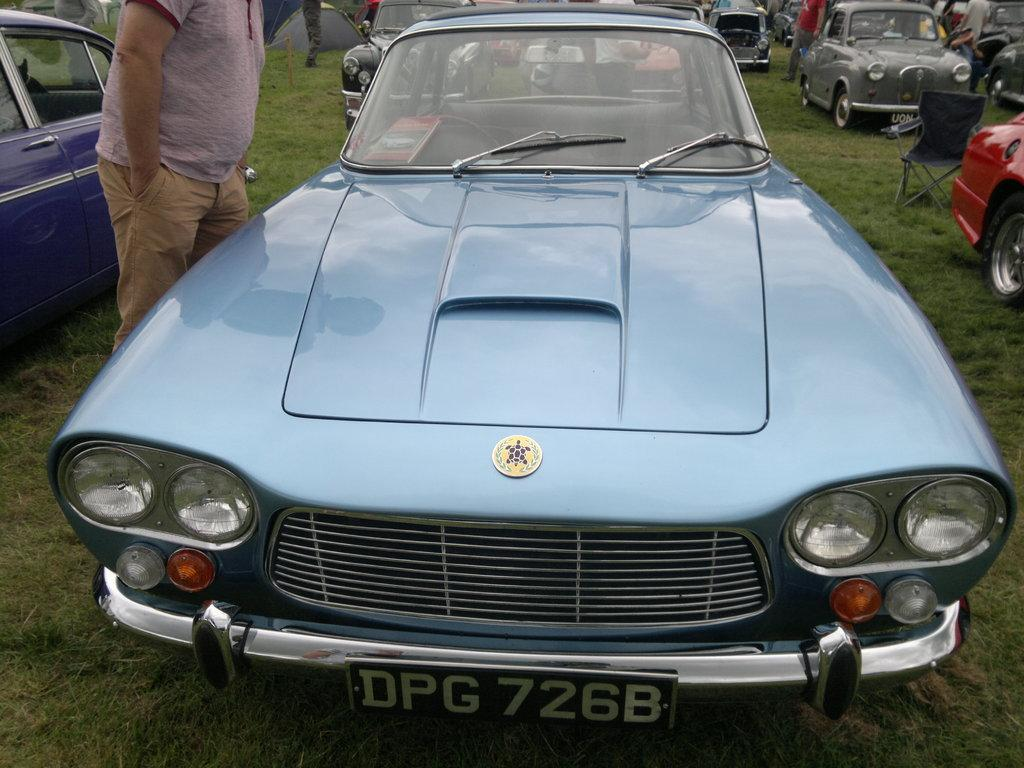What types of objects can be seen in the image? There are vehicles in the image. Are there any living beings present in the image? Yes, there are persons in the image. What can be seen beneath the vehicles and persons? The ground is visible in the image. What type of vegetation is present on the ground? There is grass on the ground in the image. What type of prose is being recited by the cork in the image? There is no cork or prose present in the image. Does the existence of the vehicles and persons in the image prove the existence of a higher power? The image does not provide any information about the existence of a higher power, nor does it make any claims about the existence of vehicles and persons proving the existence of such a power. 